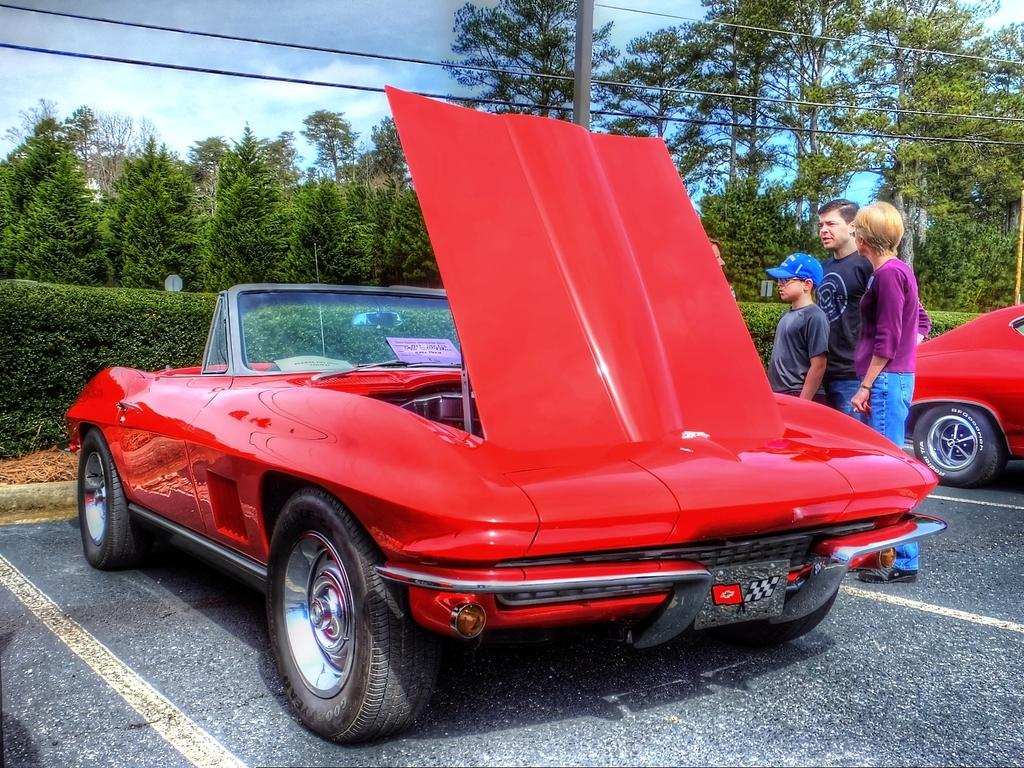How many cars are in the image? There are two cars in the image. How many people are on the road in the image? There are four persons on the road in the image. What can be seen in the background of the image? In the background of the image, there are plants, trees, wires, and the sky. What is the weather like in the image? The image was taken during a sunny day. What type of action is the cast performing in the image? There is no cast or action being performed in the image; it features two cars and four people on the road. What type of plane can be seen flying in the image? There is no plane visible in the image. 